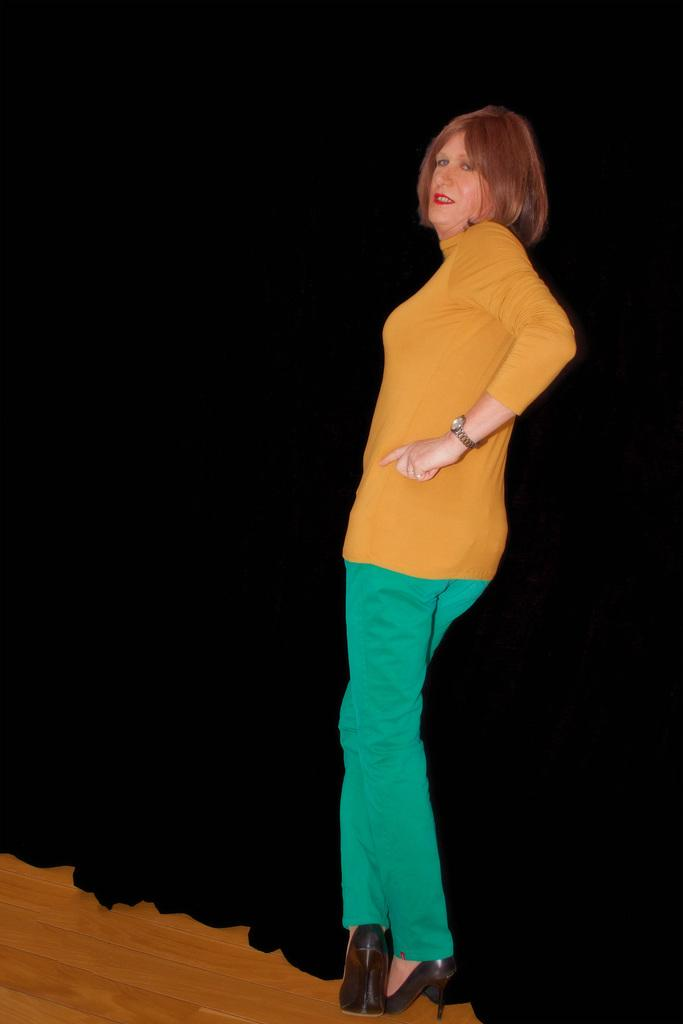What is the main subject of the image? There is a person standing in the center of the image. Can you describe the background of the image? There is a curtain in the background of the image. What date is circled on the calendar in the image? There is no calendar present in the image. What type of impulse can be seen affecting the person in the image? There is no indication of any impulse affecting the person in the image. 